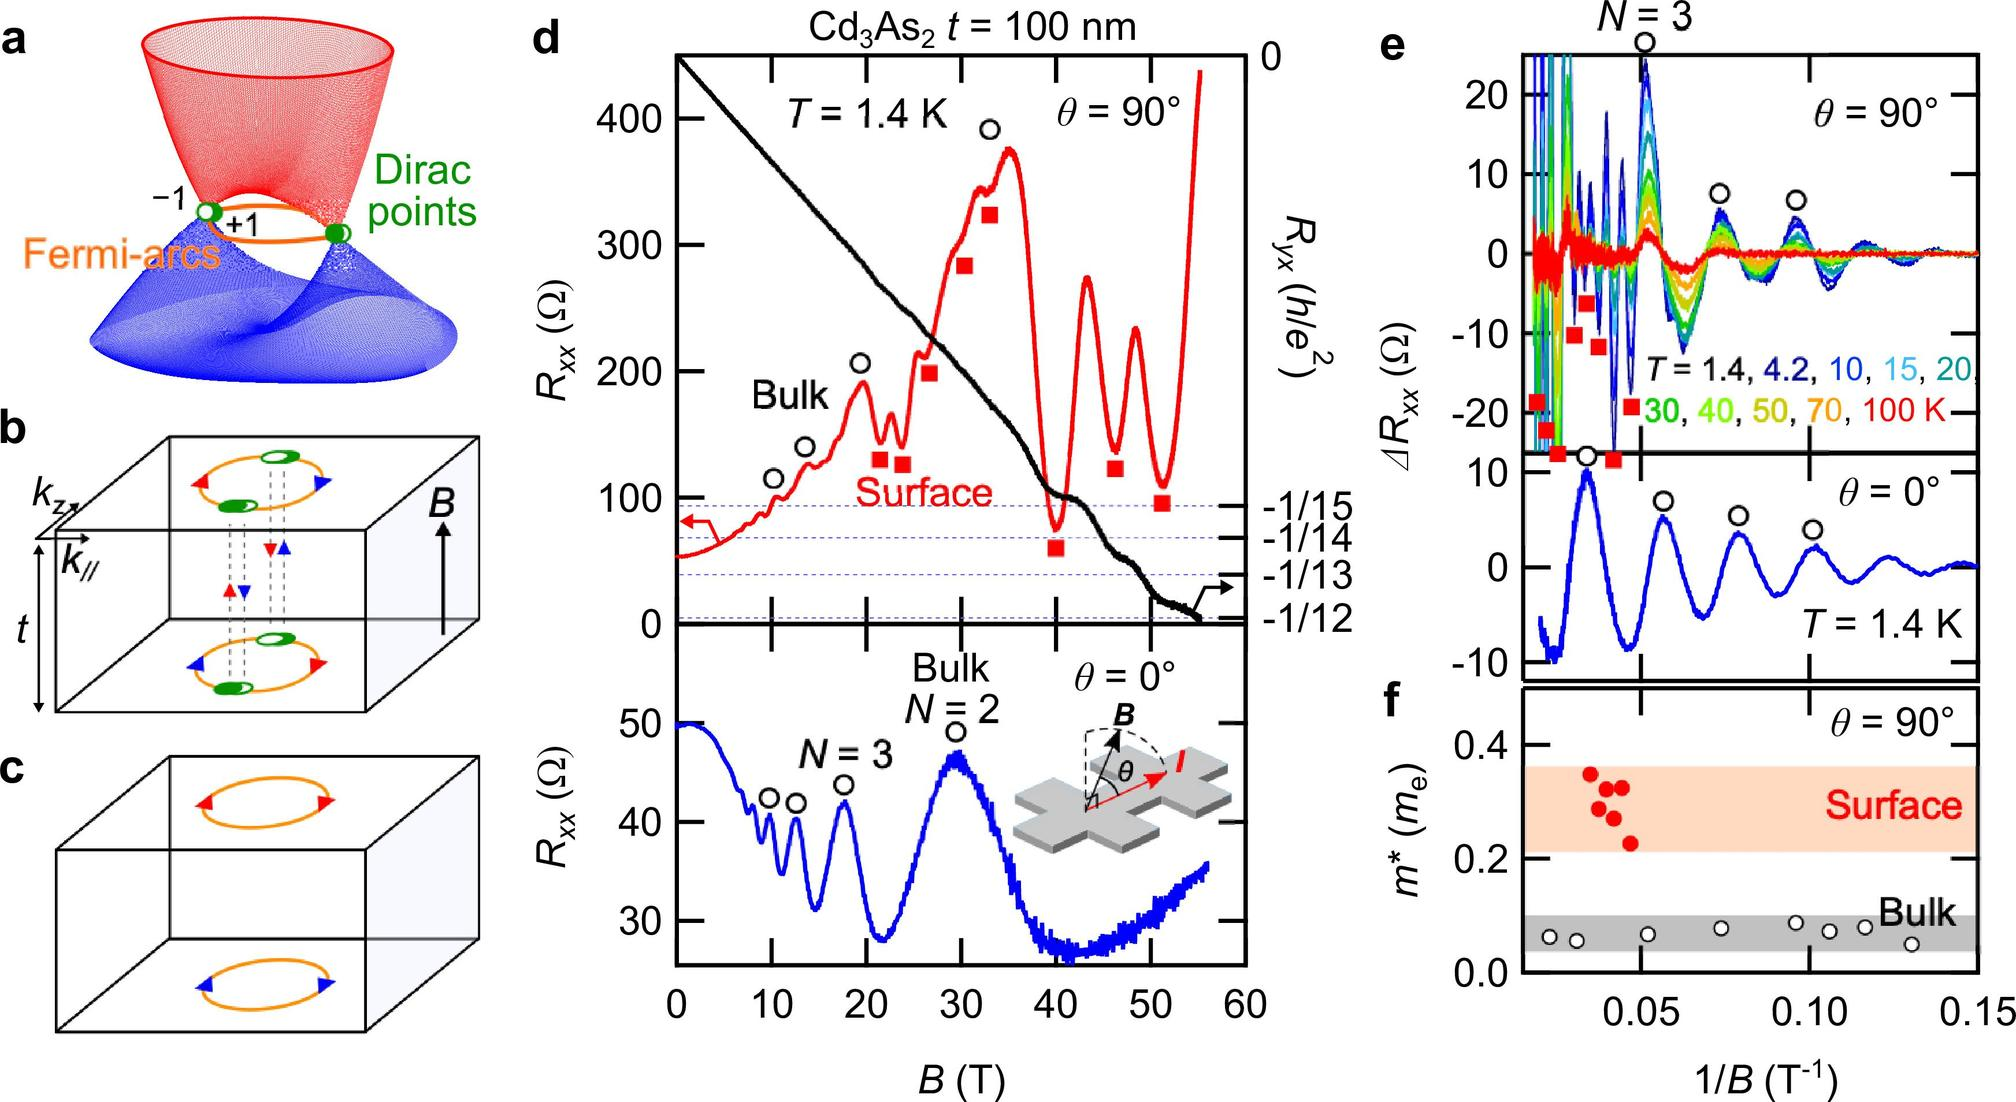Based on panel f, what is the relationship between the effective mass (m*) and the inverse of magnetic field strength (1/B) for the surface states? In panel f of the image, which presents the relationship between the effective mass (m*, shown on the vertical axis) and the inverse of magnetic field strength (1/B, shown on the horizontal axis) for surface states, we observe a stable pattern. The data points represented by red circles remain steady along a horizontal line across varying 1/B values. This indicates a uniform effective mass that does not exhibit any significant shifts with changes in magnetic field strength. Thus, m* is essentially constant relative to the changes in 1/B for these surface states. 